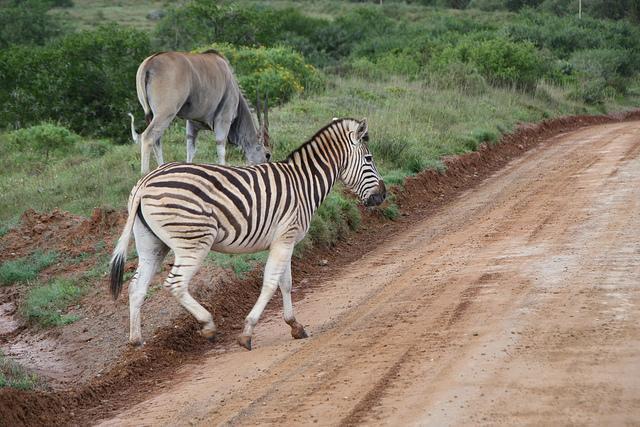How many zebras are in the picture?
Give a very brief answer. 1. 